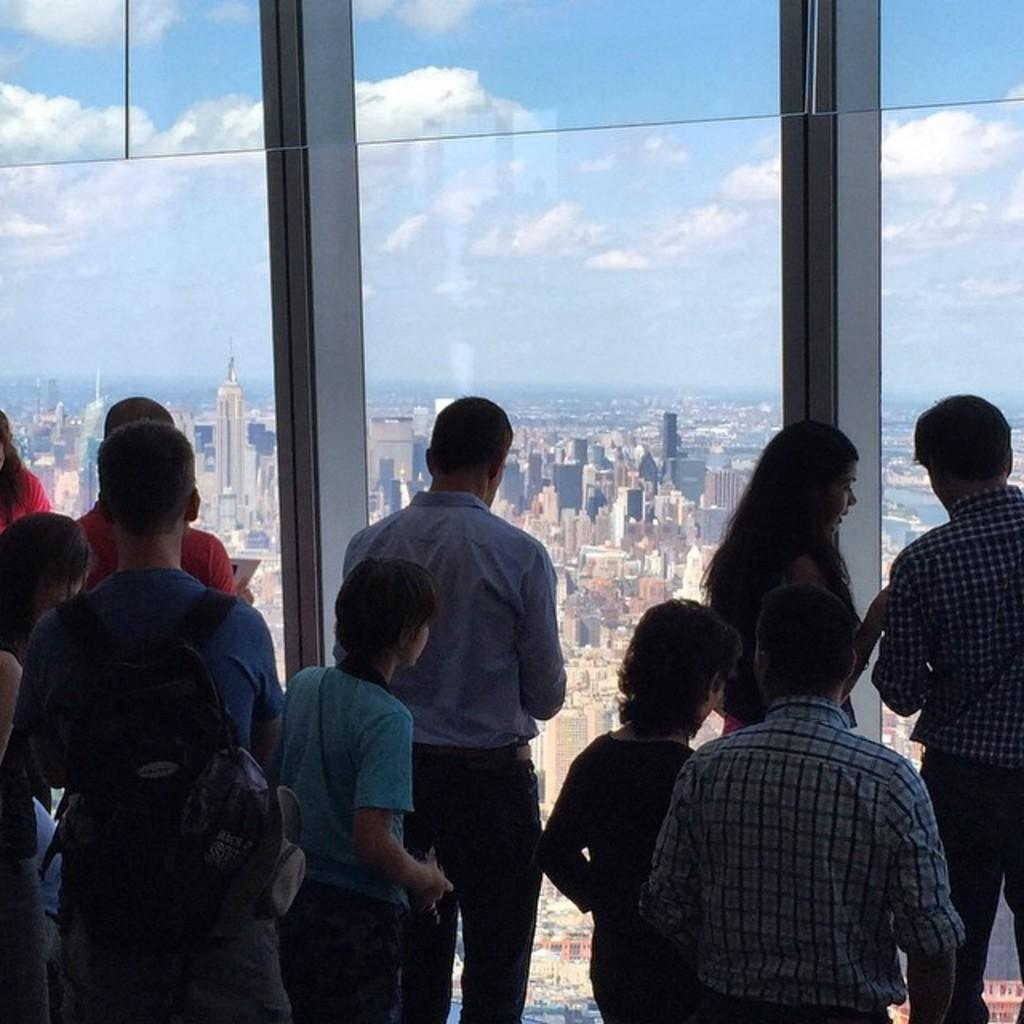Who or what can be seen in the image? There are people in the image. What object is present that allows for visibility of the surroundings? There is a transparent glass in the image. What can be seen through the glass? Buildings are visible through the glass. What part of the natural environment is visible in the image? The sky is visible in the image. What type of glove is being used in the fight depicted in the image? There is no fight or glove present in the image; it features people and a transparent glass with buildings visible through it. 